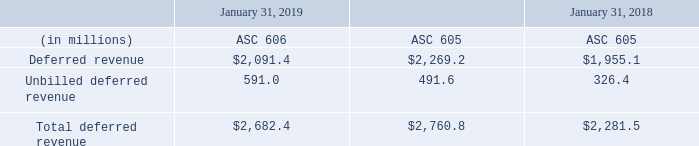Total Deferred Revenue
The adoption of ASC Topic 606 required a change to the definition of unbilled deferred revenue and new qualitative and quantitative disclosures around our performance obligations. Unbilled deferred revenue represents contractually stated or committed orders under early renewal and multi-year billing plans primarily for subscription, services and maintenance for which the associated deferred revenue has not been recognized. Under ASC Topic 606, unbilled deferred revenue is not included as a receivable or deferred revenue on our Consolidated Balance Sheet. See Part II, Item 8, Note 2, “Revenue Recognition” for more details on Autodesk's performance obligations.
We expect that the amount of billed and unbilled deferred revenue will change from quarter to quarter for several reasons, including the specific timing, duration and size of customer subscription and support agreements, varying billing cycles of such agreements, the specific timing of customer renewals, and foreign currency fluctuations
What is the percentage of total revenue that comes from unbilled deferred revenue as of January 31, 2018?
Answer scale should be: percent. (326.4/2,281.5) 
Answer: 14.31. What is the difference between the unbilled deferred revenue for ASC 605 from January 31, 2018 to January 31, 2019?
Answer scale should be: million. 491.6-326.4 
Answer: 165.2. What are possible reasons that the amount of billed and unbilled deferred revenue will change from quarter to quarter? Amount of billed and unbilled deferred revenue will change from quarter to quarter for several reasons, including the specific timing, duration and size of customer subscription and support agreements, varying billing cycles of such agreements, the specific timing of customer renewals, and foreign currency fluctuations. What is the difference between ASC 605 and ASC 606 in fiscal year 2019? The adoption of asc topic 606 required a change to the definition of unbilled deferred revenue and new qualitative and quantitative disclosures around our performance obligations., under asc topic 606, unbilled deferred revenue is not included as a receivable or deferred revenue on our consolidated balance sheet. What is the unbilled deferred revenue as of January 31, 2018? 
Answer scale should be: million. 326.4. What is the average deferred revenue from 2018 to 2019 under ASC 605?
Answer scale should be: million. (2,269.2+1,955.1)/2 
Answer: 2112.15. 